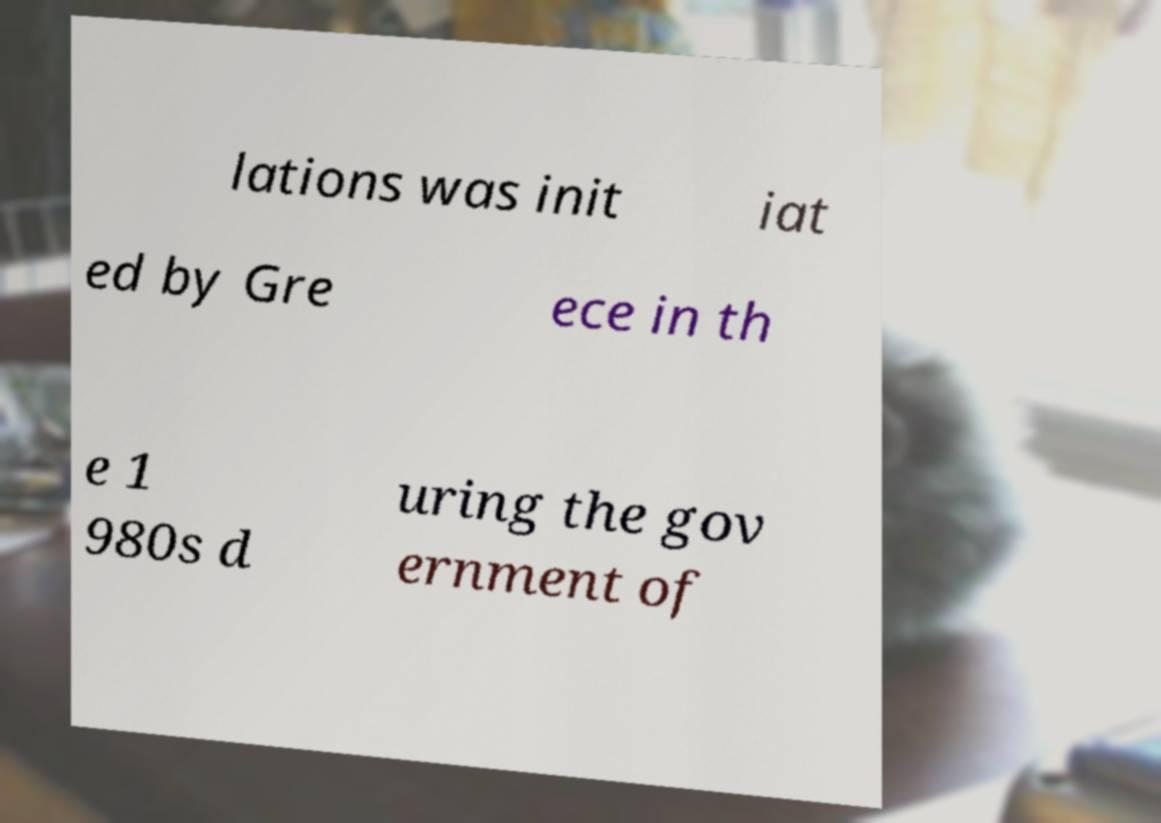Please identify and transcribe the text found in this image. lations was init iat ed by Gre ece in th e 1 980s d uring the gov ernment of 